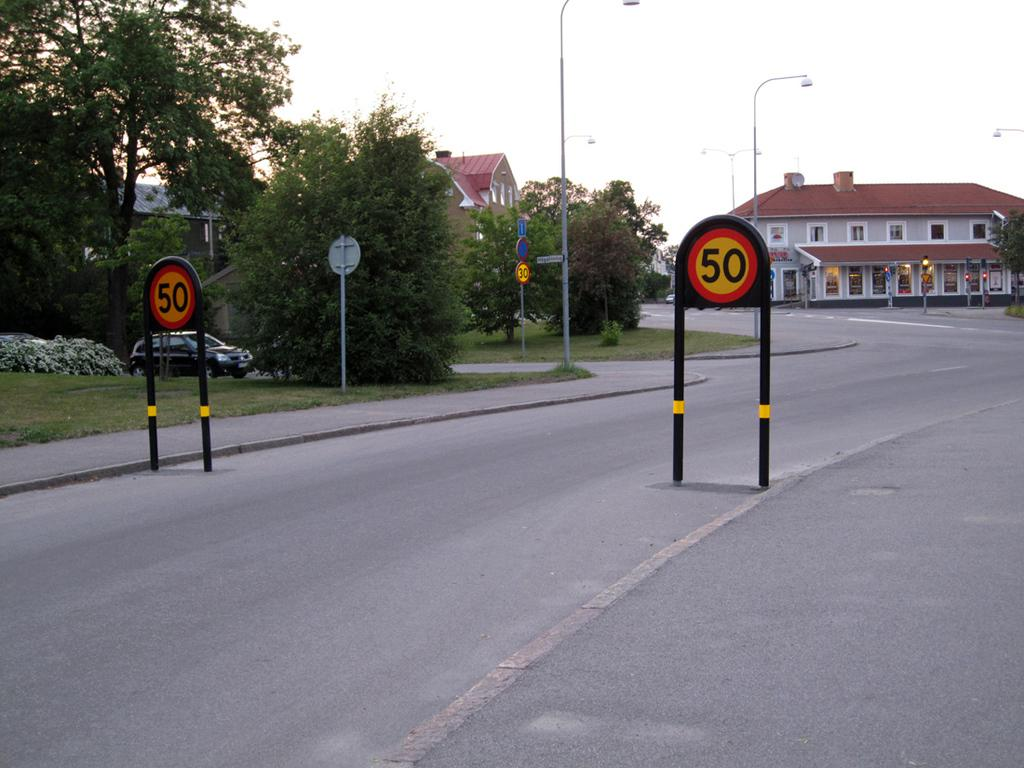Provide a one-sentence caption for the provided image. the number 50 that is on a sign outdoors. 